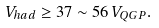<formula> <loc_0><loc_0><loc_500><loc_500>V _ { h a d } \geq 3 7 \sim 5 6 \, V _ { Q G P } .</formula> 